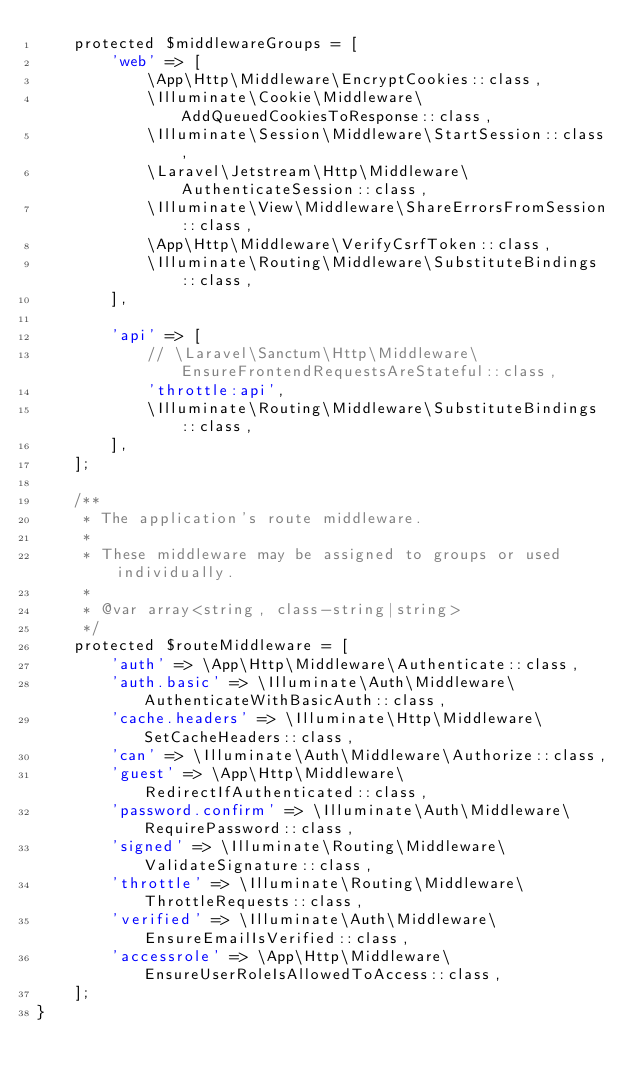<code> <loc_0><loc_0><loc_500><loc_500><_PHP_>    protected $middlewareGroups = [
        'web' => [
            \App\Http\Middleware\EncryptCookies::class,
            \Illuminate\Cookie\Middleware\AddQueuedCookiesToResponse::class,
            \Illuminate\Session\Middleware\StartSession::class,
            \Laravel\Jetstream\Http\Middleware\AuthenticateSession::class,
            \Illuminate\View\Middleware\ShareErrorsFromSession::class,
            \App\Http\Middleware\VerifyCsrfToken::class,
            \Illuminate\Routing\Middleware\SubstituteBindings::class,
        ],

        'api' => [
            // \Laravel\Sanctum\Http\Middleware\EnsureFrontendRequestsAreStateful::class,
            'throttle:api',
            \Illuminate\Routing\Middleware\SubstituteBindings::class,
        ],
    ];

    /**
     * The application's route middleware.
     *
     * These middleware may be assigned to groups or used individually.
     *
     * @var array<string, class-string|string>
     */
    protected $routeMiddleware = [
        'auth' => \App\Http\Middleware\Authenticate::class,
        'auth.basic' => \Illuminate\Auth\Middleware\AuthenticateWithBasicAuth::class,
        'cache.headers' => \Illuminate\Http\Middleware\SetCacheHeaders::class,
        'can' => \Illuminate\Auth\Middleware\Authorize::class,
        'guest' => \App\Http\Middleware\RedirectIfAuthenticated::class,
        'password.confirm' => \Illuminate\Auth\Middleware\RequirePassword::class,
        'signed' => \Illuminate\Routing\Middleware\ValidateSignature::class,
        'throttle' => \Illuminate\Routing\Middleware\ThrottleRequests::class,
        'verified' => \Illuminate\Auth\Middleware\EnsureEmailIsVerified::class,
        'accessrole' => \App\Http\Middleware\EnsureUserRoleIsAllowedToAccess::class,
    ];
}
</code> 